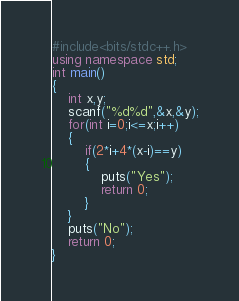<code> <loc_0><loc_0><loc_500><loc_500><_C++_>#include<bits/stdc++.h>
using namespace std;
int main()
{
	int x,y;
	scanf("%d%d",&x,&y);
	for(int i=0;i<=x;i++)
	{
		if(2*i+4*(x-i)==y)
		{
			puts("Yes");
			return 0;
		}
	}
	puts("No");
	return 0;
}</code> 